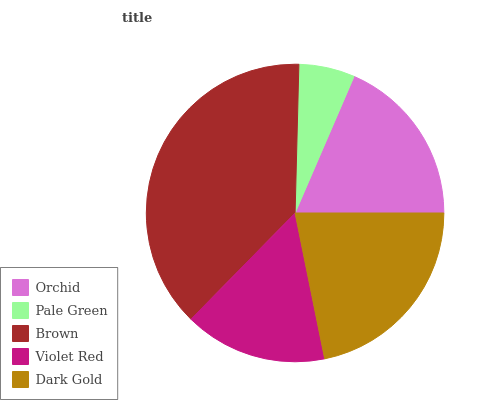Is Pale Green the minimum?
Answer yes or no. Yes. Is Brown the maximum?
Answer yes or no. Yes. Is Brown the minimum?
Answer yes or no. No. Is Pale Green the maximum?
Answer yes or no. No. Is Brown greater than Pale Green?
Answer yes or no. Yes. Is Pale Green less than Brown?
Answer yes or no. Yes. Is Pale Green greater than Brown?
Answer yes or no. No. Is Brown less than Pale Green?
Answer yes or no. No. Is Orchid the high median?
Answer yes or no. Yes. Is Orchid the low median?
Answer yes or no. Yes. Is Brown the high median?
Answer yes or no. No. Is Pale Green the low median?
Answer yes or no. No. 